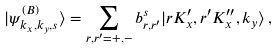<formula> <loc_0><loc_0><loc_500><loc_500>| \psi ^ { ( B ) } _ { k _ { x } , k _ { y } , s } \rangle = \sum _ { r , r ^ { \prime } = + , - } b _ { r , r ^ { \prime } } ^ { s } | r K ^ { \prime } _ { x } , r ^ { \prime } K ^ { \prime \prime } _ { x } , k _ { y } \rangle \, ,</formula> 